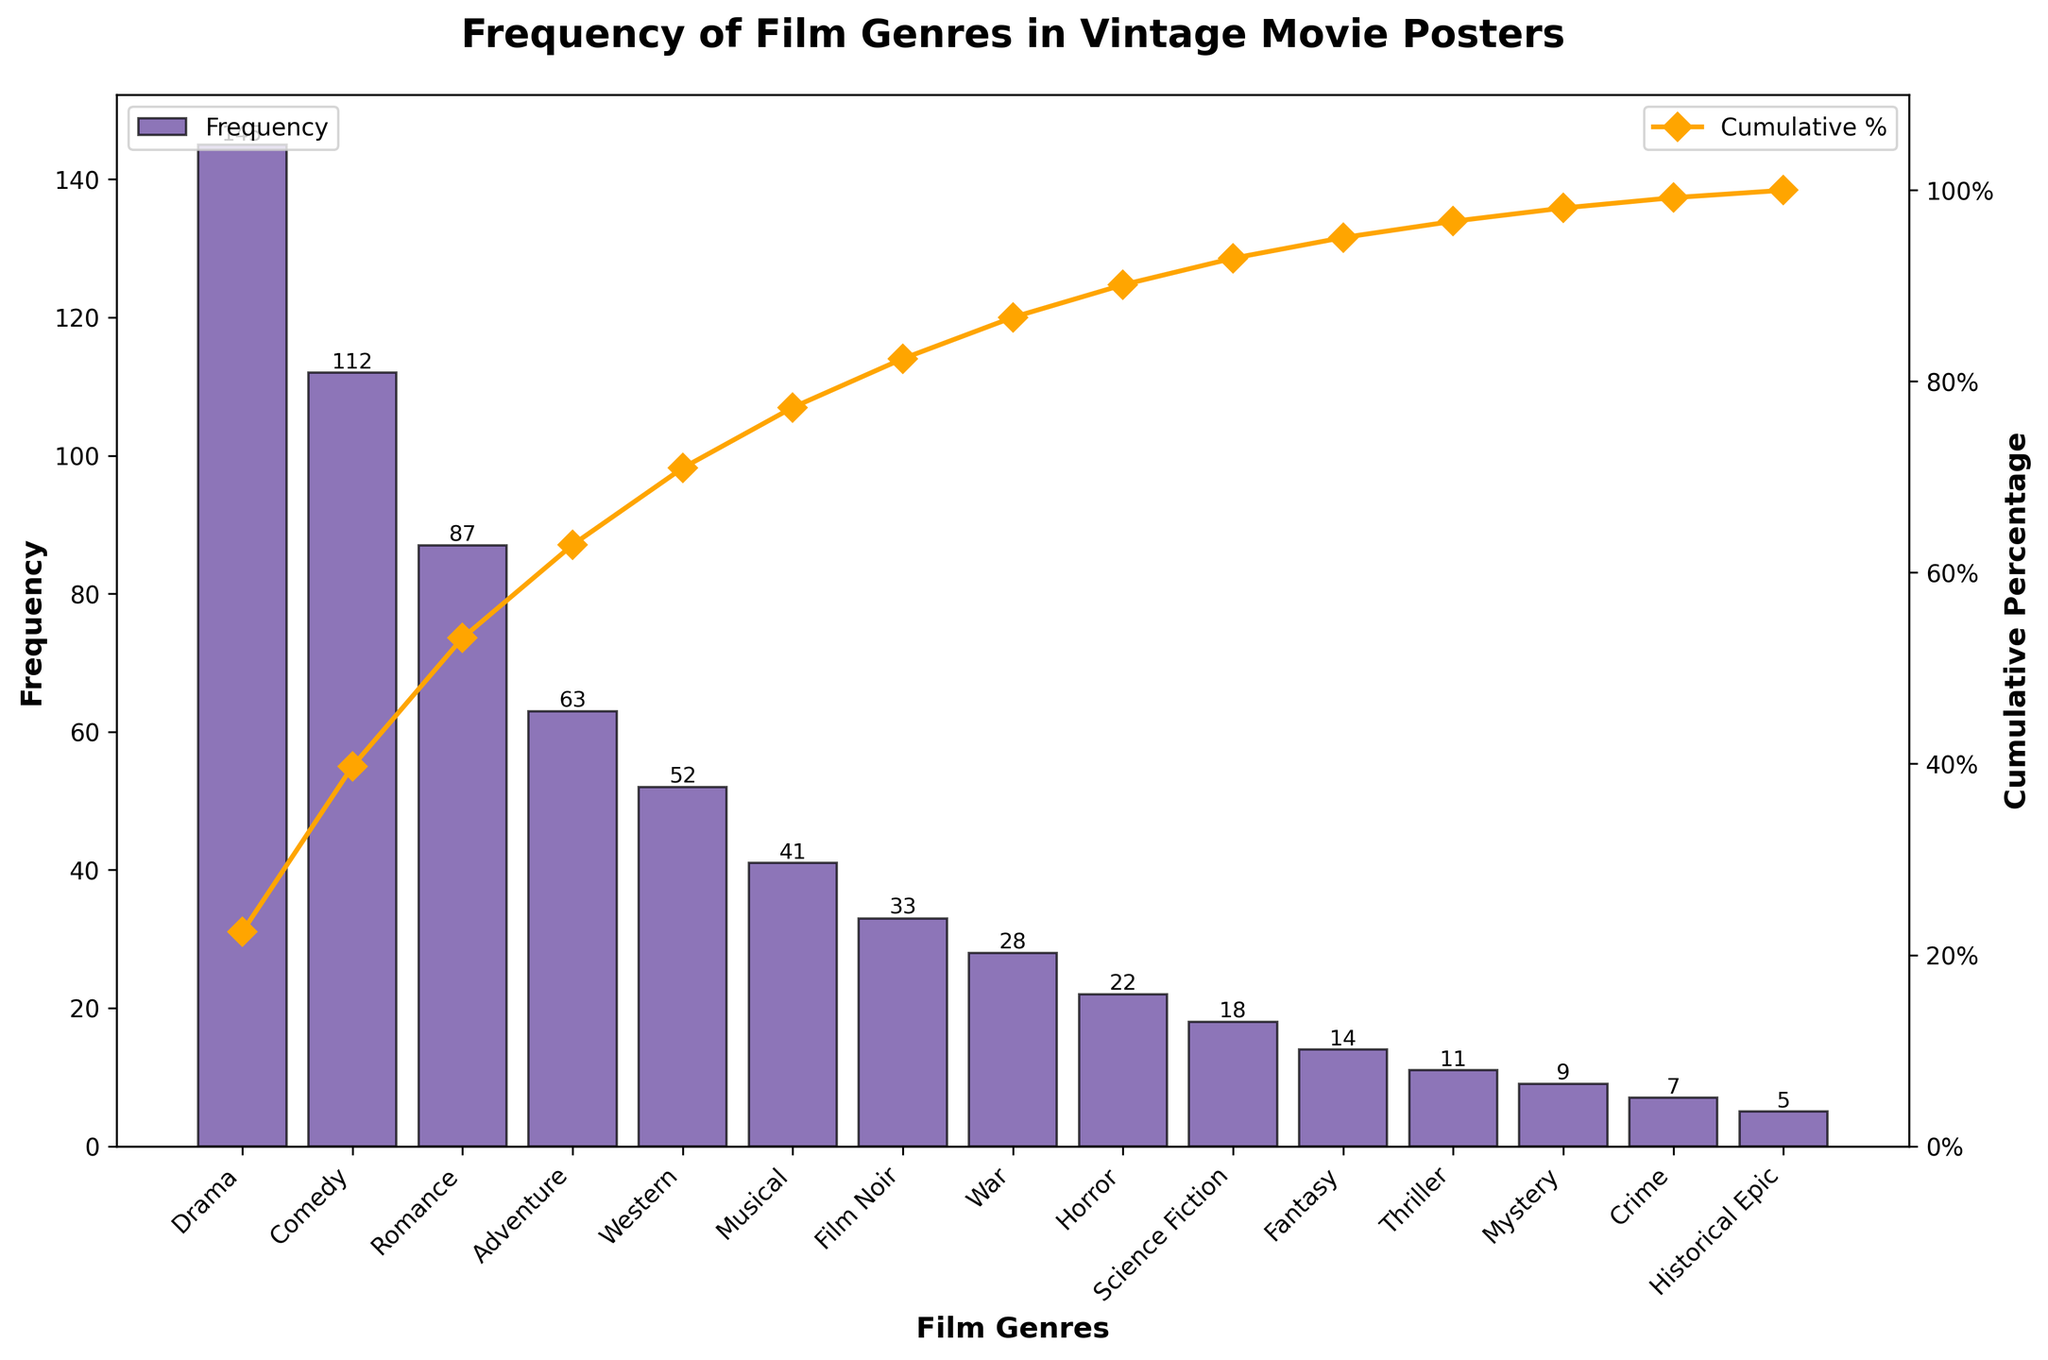What is the most common film genre represented in the vintage movie posters? The most common genre can be determined by looking at the genre with the highest bar in the bar chart. In this case, Drama has the highest frequency bar.
Answer: Drama Which genre has a cumulative percentage closest to 50%? To find the genre, we look at the line plot representing the cumulative percentage. The genre where the line crosses closest to 50% is Romance.
Answer: Romance What is the cumulative percentage for the top three most frequent film genres? The top three genres by frequency are Drama, Comedy, and Romance. Add their individual frequencies (145 + 112 + 87) and find the percentage of this sum relative to the total frequency sum. 145 + 112 + 87 = 344. The total frequency sum is 645. The cumulative percentage is (344/645) * 100 ≈ 53.49%.
Answer: About 53.49% How many genres have a frequency greater than 50? By examining the heights of the bars, we identify the genres with frequencies greater than 50: Drama, Comedy, Romance, Adventure, and Western. There are 5 such genres.
Answer: 5 Which genre has the lowest frequency? The genre with the lowest bar height represents the lowest frequency. In this case, Historical Epic has the lowest frequency.
Answer: Historical Epic What is the frequency difference between the Drama and Musical genres? To find the difference in frequency, subtract the frequency of the Musical genre from the Drama genre. 145 (Drama) - 41 (Musical) = 104.
Answer: 104 What cumulative percentage does the genre Thriller account for? To determine the cumulative percentage for Thriller, add up the frequencies of all genres up to and including Thriller, and divide by the total sum of frequencies, then multiply by 100. Summing the frequencies up to Thriller gives us: 145 + 112 + 87 + 63 + 52 + 41 + 33 + 28 + 22 + 18 + 14 + 11 = 626. The cumulative percentage is (626/645) * 100 ≈ 97.05%.
Answer: About 97.05% How many genres account for roughly 80% of the total frequency? To find out, we look at the cumulative percentage line plot and the point where it crosses 80%. The genres up to and including Western give us: Drama, Comedy, Romance, Adventure, and Western. This group provides a cumulative percentage of over 80%.
Answer: 5 What is the combined frequency of Horror, Science Fiction, Fantasy, and Thriller genres? Add the frequencies of these genres: Horror (22), Science Fiction (18), Fantasy (14), and Thriller (11). 22 + 18 + 14 + 11 = 65.
Answer: 65 Which genre's cumulative percentage mark is closest to the 20% mark? By examining the cumulative percentage line plot, we find that the Comedy genre is the closest to the 20% cumulative percentage mark.
Answer: Comedy 